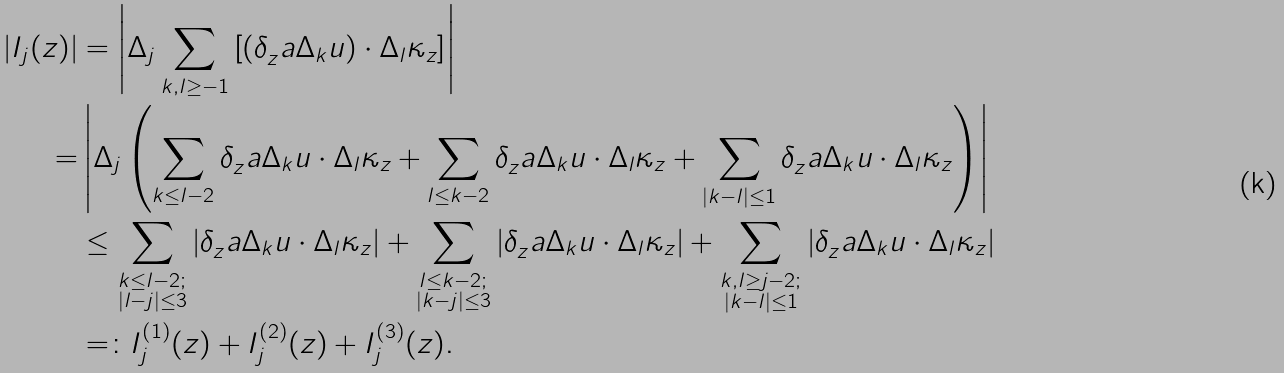Convert formula to latex. <formula><loc_0><loc_0><loc_500><loc_500>| I _ { j } ( z ) | & = \left | \Delta _ { j } \sum _ { k , l \geq - 1 } \left [ ( \delta _ { z } ^ { \ } a \Delta _ { k } u ) \cdot \Delta _ { l } \kappa _ { z } \right ] \right | \\ = & \left | \Delta _ { j } \left ( \sum _ { k \leq l - 2 } \delta _ { z } ^ { \ } a \Delta _ { k } u \cdot \Delta _ { l } \kappa _ { z } + \sum _ { l \leq k - 2 } \delta _ { z } ^ { \ } a \Delta _ { k } u \cdot \Delta _ { l } \kappa _ { z } + \sum _ { | k - l | \leq 1 } \delta _ { z } ^ { \ } a \Delta _ { k } u \cdot \Delta _ { l } \kappa _ { z } \right ) \right | \\ & \leq \sum _ { \substack { k \leq l - 2 ; \\ | l - j | \leq 3 } } \left | \delta _ { z } ^ { \ } a \Delta _ { k } u \cdot \Delta _ { l } \kappa _ { z } \right | + \sum _ { \substack { l \leq k - 2 ; \\ | k - j | \leq 3 } } \left | \delta _ { z } ^ { \ } a \Delta _ { k } u \cdot \Delta _ { l } \kappa _ { z } \right | + \sum _ { \substack { k , l \geq j - 2 ; \\ | k - l | \leq 1 } } \left | \delta _ { z } ^ { \ } a \Delta _ { k } u \cdot \Delta _ { l } \kappa _ { z } \right | \\ & = \colon I ^ { ( 1 ) } _ { j } ( z ) + I ^ { ( 2 ) } _ { j } ( z ) + I ^ { ( 3 ) } _ { j } ( z ) .</formula> 